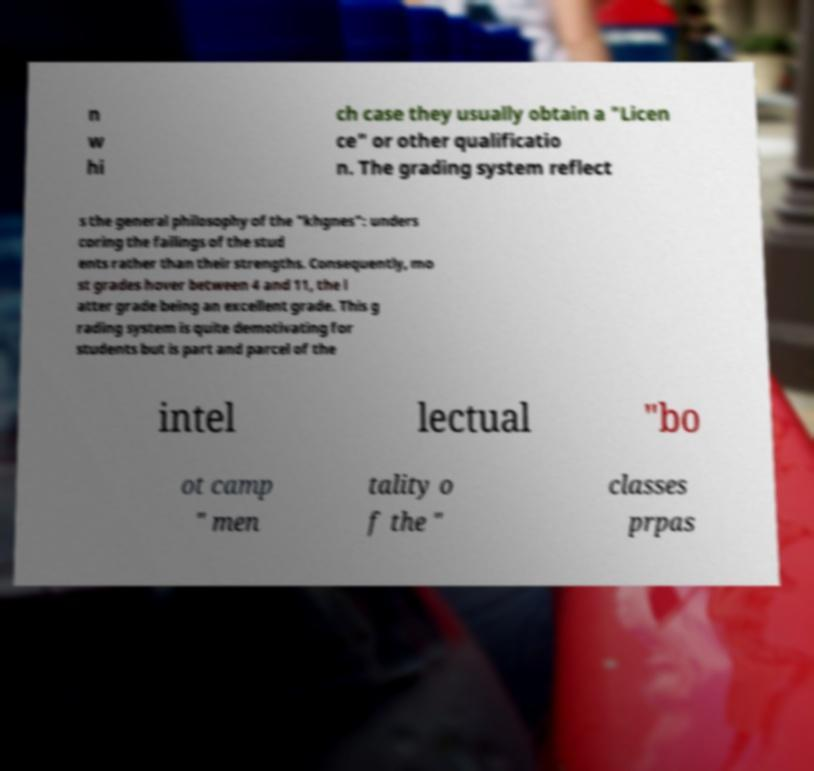What messages or text are displayed in this image? I need them in a readable, typed format. n w hi ch case they usually obtain a "Licen ce" or other qualificatio n. The grading system reflect s the general philosophy of the "khgnes": unders coring the failings of the stud ents rather than their strengths. Consequently, mo st grades hover between 4 and 11, the l atter grade being an excellent grade. This g rading system is quite demotivating for students but is part and parcel of the intel lectual "bo ot camp " men tality o f the " classes prpas 